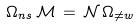<formula> <loc_0><loc_0><loc_500><loc_500>\Omega _ { n s } \, \mathcal { M } \, = \, \mathcal { N } \, \Omega _ { \ne w }</formula> 